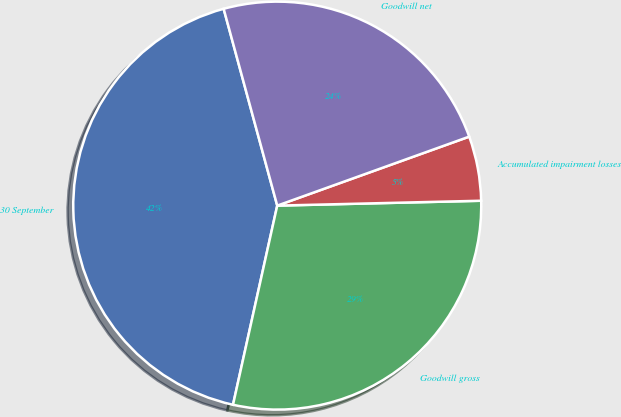Convert chart to OTSL. <chart><loc_0><loc_0><loc_500><loc_500><pie_chart><fcel>30 September<fcel>Goodwill gross<fcel>Accumulated impairment losses<fcel>Goodwill net<nl><fcel>42.29%<fcel>28.86%<fcel>5.11%<fcel>23.74%<nl></chart> 